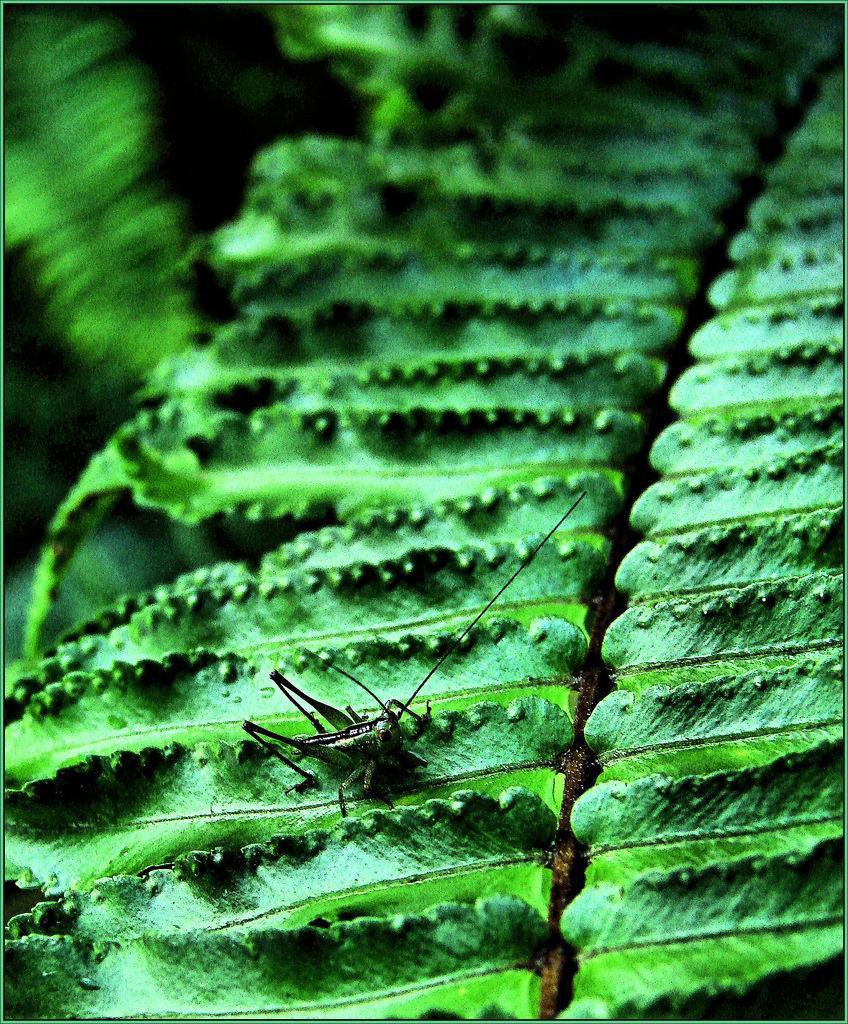In one or two sentences, can you explain what this image depicts? In this image in the foreground there is a leaf, and on the leaf there is an insect. 